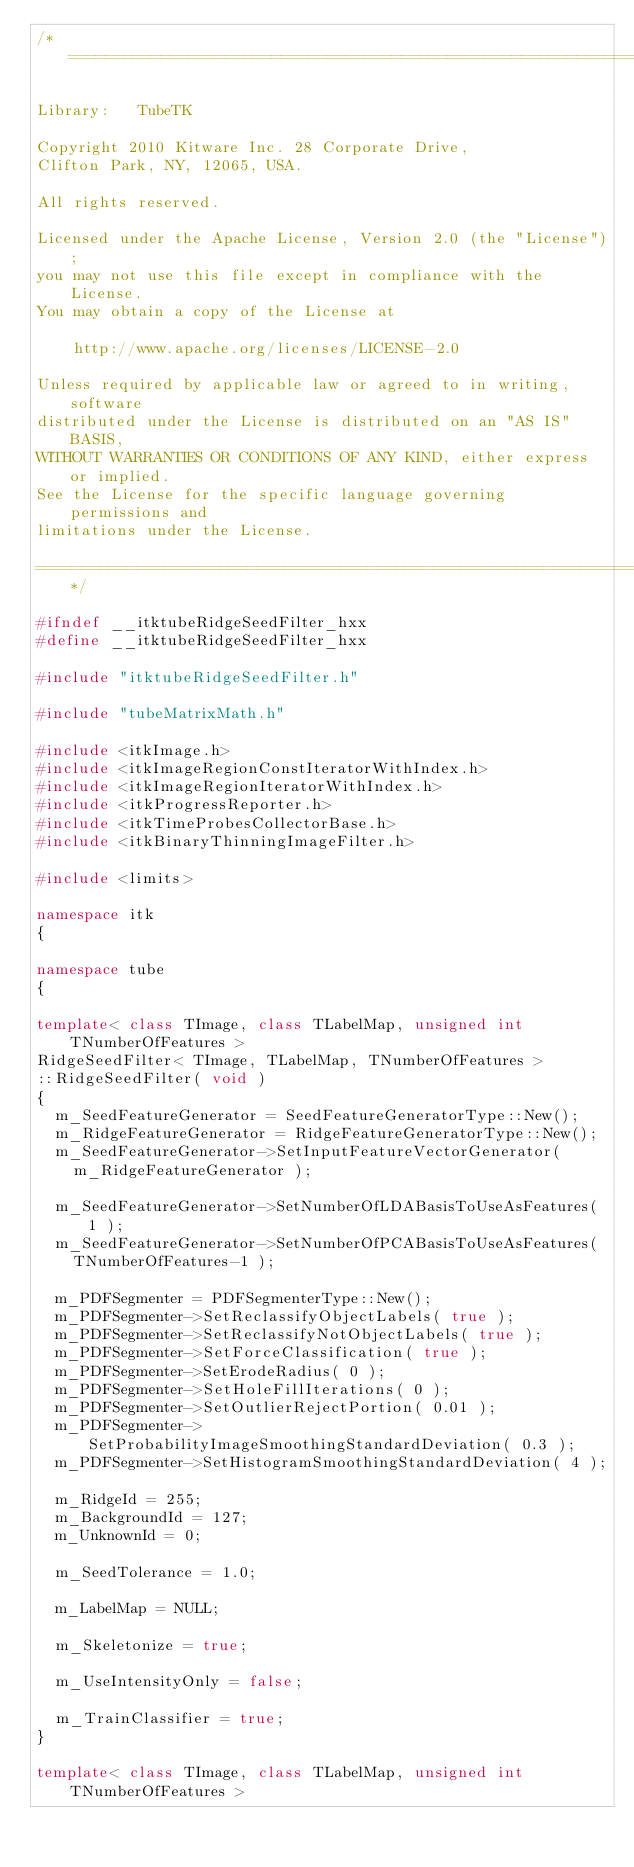<code> <loc_0><loc_0><loc_500><loc_500><_C++_>/*=========================================================================

Library:   TubeTK

Copyright 2010 Kitware Inc. 28 Corporate Drive,
Clifton Park, NY, 12065, USA.

All rights reserved.

Licensed under the Apache License, Version 2.0 (the "License");
you may not use this file except in compliance with the License.
You may obtain a copy of the License at

    http://www.apache.org/licenses/LICENSE-2.0

Unless required by applicable law or agreed to in writing, software
distributed under the License is distributed on an "AS IS" BASIS,
WITHOUT WARRANTIES OR CONDITIONS OF ANY KIND, either express or implied.
See the License for the specific language governing permissions and
limitations under the License.

=========================================================================*/

#ifndef __itktubeRidgeSeedFilter_hxx
#define __itktubeRidgeSeedFilter_hxx

#include "itktubeRidgeSeedFilter.h"

#include "tubeMatrixMath.h"

#include <itkImage.h>
#include <itkImageRegionConstIteratorWithIndex.h>
#include <itkImageRegionIteratorWithIndex.h>
#include <itkProgressReporter.h>
#include <itkTimeProbesCollectorBase.h>
#include <itkBinaryThinningImageFilter.h>

#include <limits>

namespace itk
{

namespace tube
{

template< class TImage, class TLabelMap, unsigned int TNumberOfFeatures >
RidgeSeedFilter< TImage, TLabelMap, TNumberOfFeatures >
::RidgeSeedFilter( void )
{
  m_SeedFeatureGenerator = SeedFeatureGeneratorType::New();
  m_RidgeFeatureGenerator = RidgeFeatureGeneratorType::New();
  m_SeedFeatureGenerator->SetInputFeatureVectorGenerator(
    m_RidgeFeatureGenerator );

  m_SeedFeatureGenerator->SetNumberOfLDABasisToUseAsFeatures( 1 );
  m_SeedFeatureGenerator->SetNumberOfPCABasisToUseAsFeatures(
    TNumberOfFeatures-1 );

  m_PDFSegmenter = PDFSegmenterType::New();
  m_PDFSegmenter->SetReclassifyObjectLabels( true );
  m_PDFSegmenter->SetReclassifyNotObjectLabels( true );
  m_PDFSegmenter->SetForceClassification( true );
  m_PDFSegmenter->SetErodeRadius( 0 );
  m_PDFSegmenter->SetHoleFillIterations( 0 );
  m_PDFSegmenter->SetOutlierRejectPortion( 0.01 );
  m_PDFSegmenter->SetProbabilityImageSmoothingStandardDeviation( 0.3 );
  m_PDFSegmenter->SetHistogramSmoothingStandardDeviation( 4 );

  m_RidgeId = 255;
  m_BackgroundId = 127;
  m_UnknownId = 0;

  m_SeedTolerance = 1.0;

  m_LabelMap = NULL;

  m_Skeletonize = true;

  m_UseIntensityOnly = false;

  m_TrainClassifier = true;
}

template< class TImage, class TLabelMap, unsigned int TNumberOfFeatures ></code> 